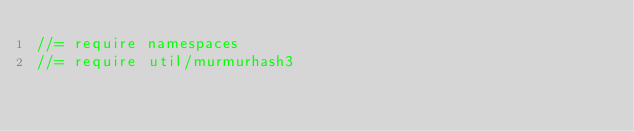<code> <loc_0><loc_0><loc_500><loc_500><_JavaScript_>//= require namespaces
//= require util/murmurhash3</code> 